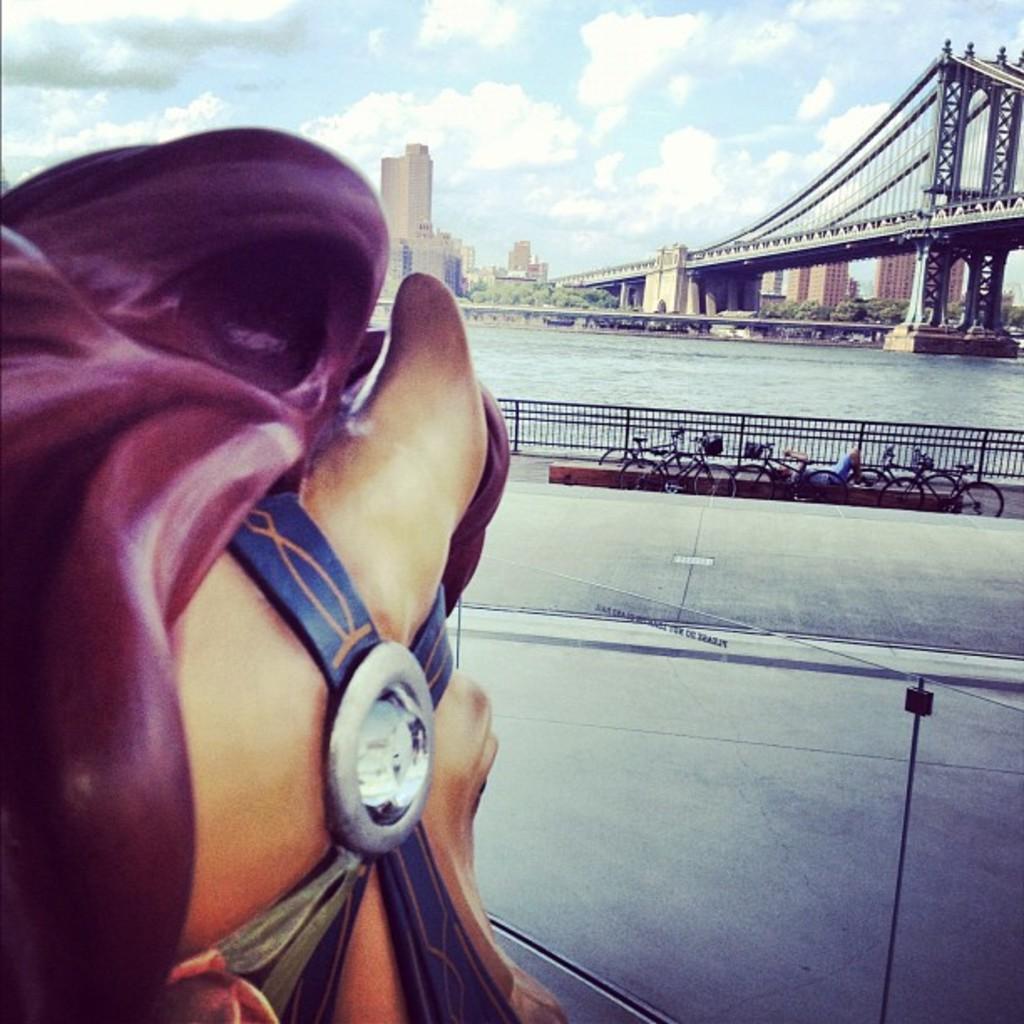How would you summarize this image in a sentence or two? In this picture we can see bicycles, fence, road, water, bridge, trees, buildings and in the background we can see the sky with clouds. 